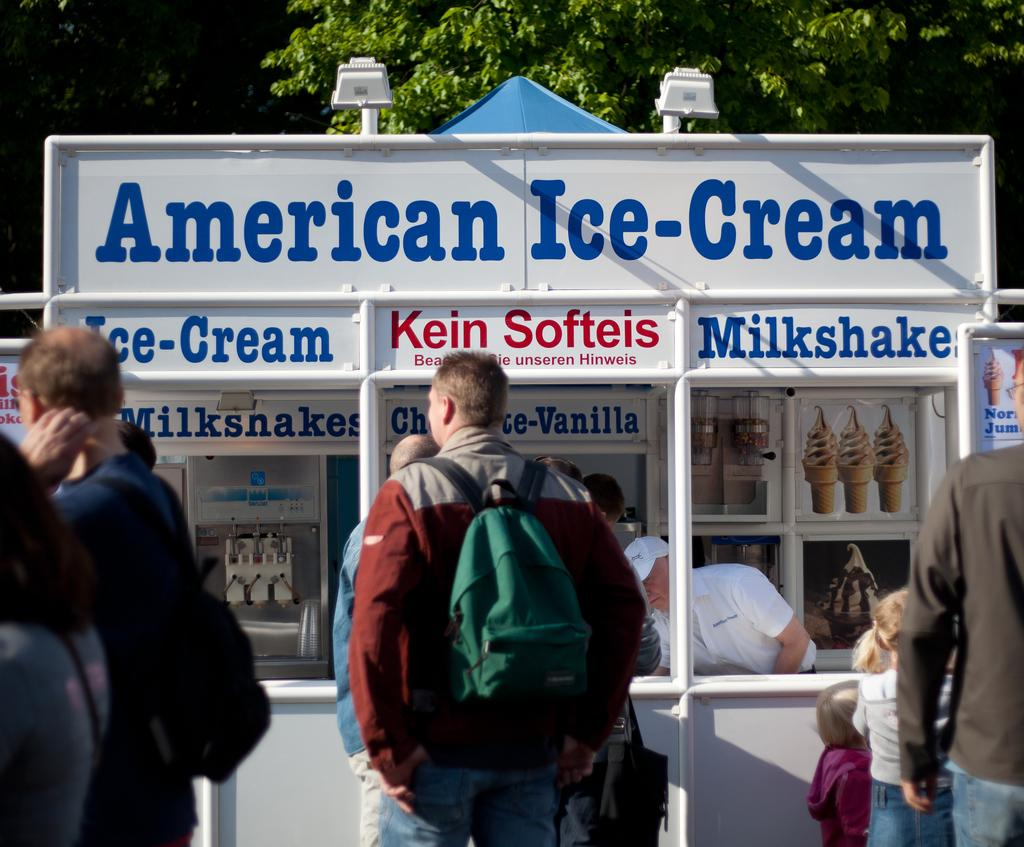What is the main subject of the picture? The main subject of the picture is an ice cream stall. Can you describe any people in the image? Yes, there is a person carrying a bag in the picture. What can be seen in terms of lighting in the image? There are lights visible in the picture. What type of seed is being planted in the picture? There is no seed or planting activity depicted in the image; it features an ice cream stall and a person carrying a bag. 